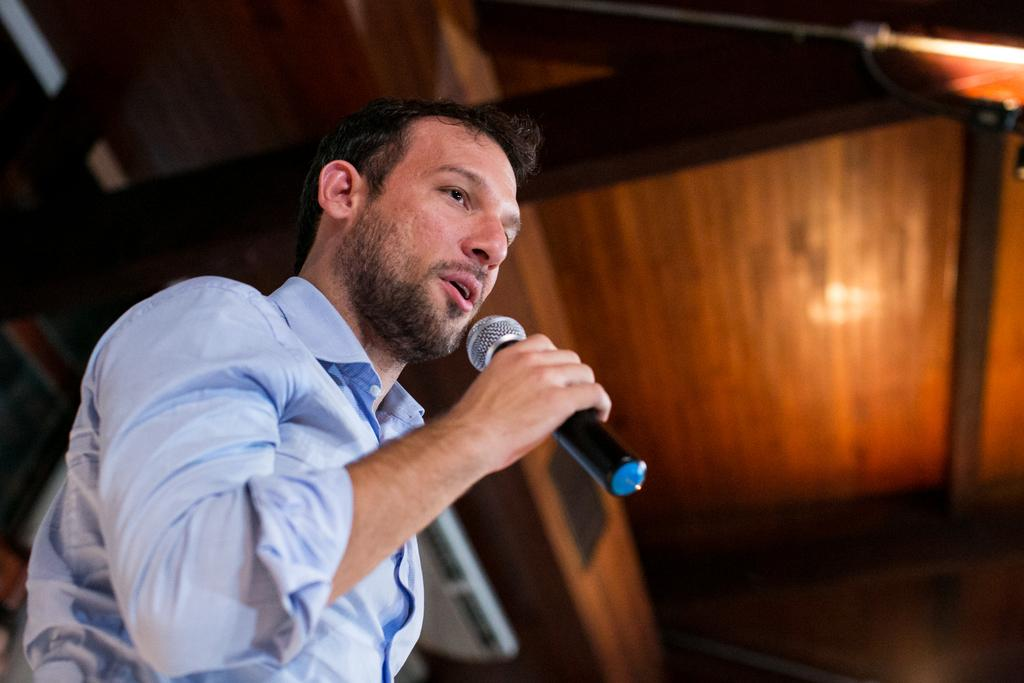Who is the main subject in the image? There is a man in the image. What is the man holding in his hand? The man is holding a microphone in his hand. What is the man doing with the microphone? The man is talking. What can be seen in the background of the image? There is a wooden ceiling in the background of the image. What type of pet is sitting on the man's shoulder in the image? There is no pet present on the man's shoulder in the image. How many stamps are visible on the man's shirt in the image? There are no stamps visible on the man's shirt in the image. 